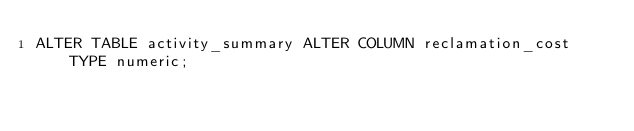<code> <loc_0><loc_0><loc_500><loc_500><_SQL_>ALTER TABLE activity_summary ALTER COLUMN reclamation_cost TYPE numeric;</code> 